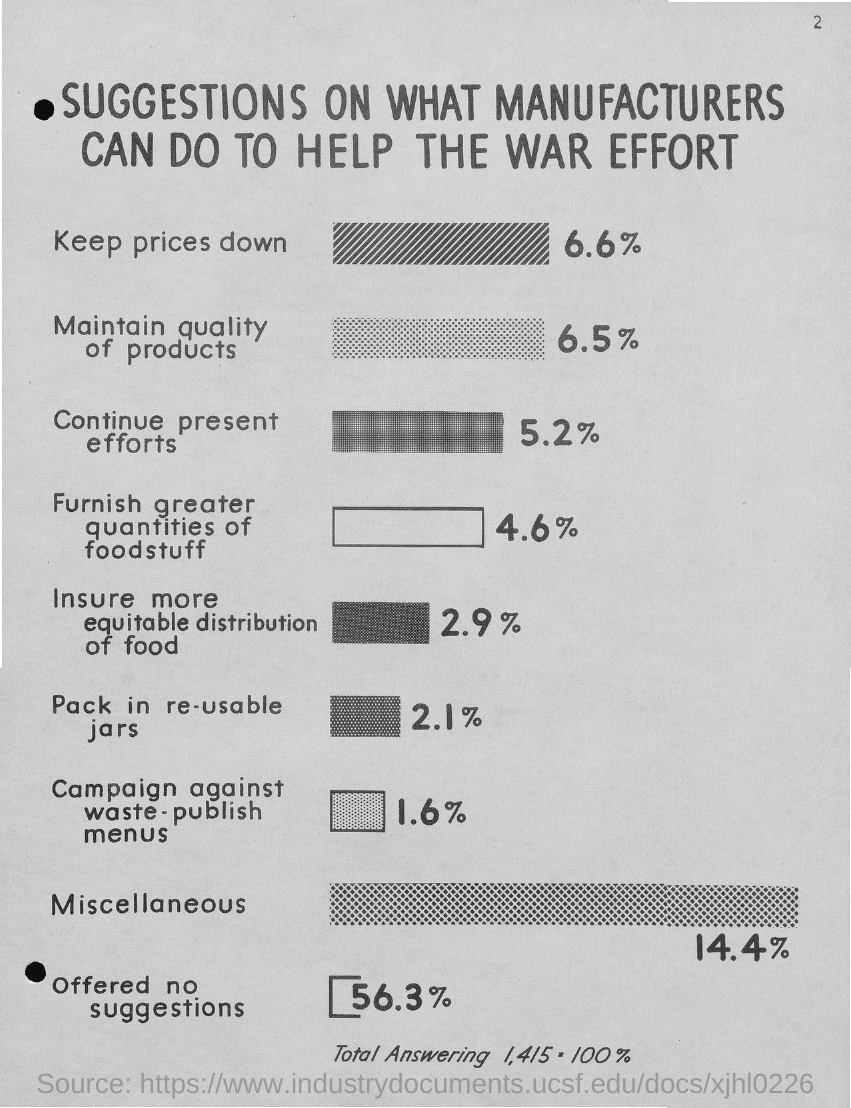Draw attention to some important aspects in this diagram. The title of the document is 'Suggestions on what manufacturers can do to help the war effort.' 